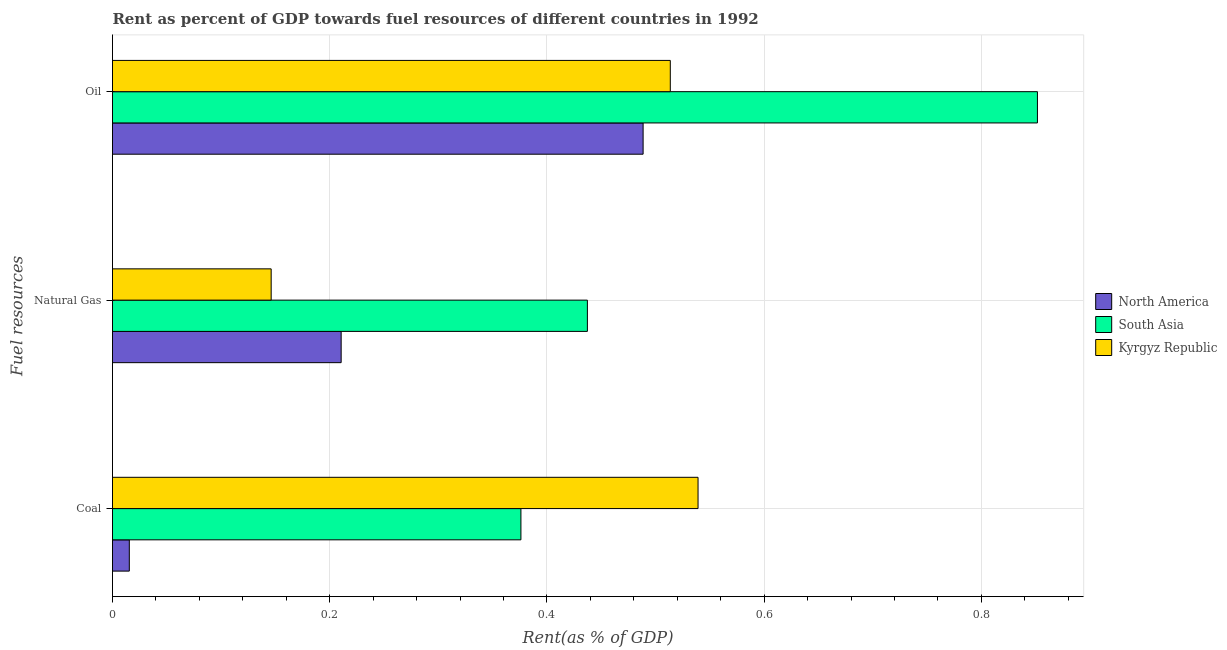How many different coloured bars are there?
Provide a succinct answer. 3. How many groups of bars are there?
Your response must be concise. 3. Are the number of bars on each tick of the Y-axis equal?
Keep it short and to the point. Yes. How many bars are there on the 2nd tick from the bottom?
Give a very brief answer. 3. What is the label of the 2nd group of bars from the top?
Your answer should be very brief. Natural Gas. What is the rent towards coal in Kyrgyz Republic?
Keep it short and to the point. 0.54. Across all countries, what is the maximum rent towards natural gas?
Keep it short and to the point. 0.44. Across all countries, what is the minimum rent towards natural gas?
Provide a succinct answer. 0.15. In which country was the rent towards coal maximum?
Give a very brief answer. Kyrgyz Republic. In which country was the rent towards natural gas minimum?
Your answer should be very brief. Kyrgyz Republic. What is the total rent towards oil in the graph?
Ensure brevity in your answer.  1.85. What is the difference between the rent towards coal in South Asia and that in North America?
Your response must be concise. 0.36. What is the difference between the rent towards natural gas in North America and the rent towards coal in South Asia?
Keep it short and to the point. -0.17. What is the average rent towards coal per country?
Offer a very short reply. 0.31. What is the difference between the rent towards natural gas and rent towards coal in Kyrgyz Republic?
Offer a very short reply. -0.39. What is the ratio of the rent towards coal in Kyrgyz Republic to that in South Asia?
Provide a short and direct response. 1.43. What is the difference between the highest and the second highest rent towards natural gas?
Offer a very short reply. 0.23. What is the difference between the highest and the lowest rent towards natural gas?
Keep it short and to the point. 0.29. Is the sum of the rent towards coal in South Asia and North America greater than the maximum rent towards natural gas across all countries?
Your answer should be very brief. No. What does the 3rd bar from the top in Coal represents?
Give a very brief answer. North America. What does the 3rd bar from the bottom in Natural Gas represents?
Provide a succinct answer. Kyrgyz Republic. How many bars are there?
Provide a short and direct response. 9. Are the values on the major ticks of X-axis written in scientific E-notation?
Keep it short and to the point. No. Does the graph contain any zero values?
Your answer should be very brief. No. Does the graph contain grids?
Give a very brief answer. Yes. What is the title of the graph?
Offer a very short reply. Rent as percent of GDP towards fuel resources of different countries in 1992. Does "Arab World" appear as one of the legend labels in the graph?
Ensure brevity in your answer.  No. What is the label or title of the X-axis?
Offer a terse response. Rent(as % of GDP). What is the label or title of the Y-axis?
Provide a succinct answer. Fuel resources. What is the Rent(as % of GDP) of North America in Coal?
Provide a short and direct response. 0.02. What is the Rent(as % of GDP) in South Asia in Coal?
Make the answer very short. 0.38. What is the Rent(as % of GDP) of Kyrgyz Republic in Coal?
Give a very brief answer. 0.54. What is the Rent(as % of GDP) in North America in Natural Gas?
Your response must be concise. 0.21. What is the Rent(as % of GDP) in South Asia in Natural Gas?
Your response must be concise. 0.44. What is the Rent(as % of GDP) of Kyrgyz Republic in Natural Gas?
Make the answer very short. 0.15. What is the Rent(as % of GDP) of North America in Oil?
Provide a short and direct response. 0.49. What is the Rent(as % of GDP) of South Asia in Oil?
Your answer should be very brief. 0.85. What is the Rent(as % of GDP) in Kyrgyz Republic in Oil?
Offer a terse response. 0.51. Across all Fuel resources, what is the maximum Rent(as % of GDP) in North America?
Your answer should be very brief. 0.49. Across all Fuel resources, what is the maximum Rent(as % of GDP) of South Asia?
Your answer should be compact. 0.85. Across all Fuel resources, what is the maximum Rent(as % of GDP) in Kyrgyz Republic?
Your answer should be very brief. 0.54. Across all Fuel resources, what is the minimum Rent(as % of GDP) of North America?
Provide a succinct answer. 0.02. Across all Fuel resources, what is the minimum Rent(as % of GDP) in South Asia?
Offer a very short reply. 0.38. Across all Fuel resources, what is the minimum Rent(as % of GDP) of Kyrgyz Republic?
Offer a terse response. 0.15. What is the total Rent(as % of GDP) of North America in the graph?
Provide a short and direct response. 0.71. What is the total Rent(as % of GDP) of South Asia in the graph?
Give a very brief answer. 1.66. What is the total Rent(as % of GDP) of Kyrgyz Republic in the graph?
Ensure brevity in your answer.  1.2. What is the difference between the Rent(as % of GDP) of North America in Coal and that in Natural Gas?
Keep it short and to the point. -0.2. What is the difference between the Rent(as % of GDP) of South Asia in Coal and that in Natural Gas?
Ensure brevity in your answer.  -0.06. What is the difference between the Rent(as % of GDP) in Kyrgyz Republic in Coal and that in Natural Gas?
Make the answer very short. 0.39. What is the difference between the Rent(as % of GDP) of North America in Coal and that in Oil?
Provide a short and direct response. -0.47. What is the difference between the Rent(as % of GDP) in South Asia in Coal and that in Oil?
Provide a succinct answer. -0.48. What is the difference between the Rent(as % of GDP) of Kyrgyz Republic in Coal and that in Oil?
Give a very brief answer. 0.03. What is the difference between the Rent(as % of GDP) of North America in Natural Gas and that in Oil?
Provide a short and direct response. -0.28. What is the difference between the Rent(as % of GDP) of South Asia in Natural Gas and that in Oil?
Keep it short and to the point. -0.41. What is the difference between the Rent(as % of GDP) in Kyrgyz Republic in Natural Gas and that in Oil?
Give a very brief answer. -0.37. What is the difference between the Rent(as % of GDP) of North America in Coal and the Rent(as % of GDP) of South Asia in Natural Gas?
Provide a succinct answer. -0.42. What is the difference between the Rent(as % of GDP) of North America in Coal and the Rent(as % of GDP) of Kyrgyz Republic in Natural Gas?
Your answer should be compact. -0.13. What is the difference between the Rent(as % of GDP) of South Asia in Coal and the Rent(as % of GDP) of Kyrgyz Republic in Natural Gas?
Provide a succinct answer. 0.23. What is the difference between the Rent(as % of GDP) of North America in Coal and the Rent(as % of GDP) of South Asia in Oil?
Your answer should be compact. -0.84. What is the difference between the Rent(as % of GDP) of North America in Coal and the Rent(as % of GDP) of Kyrgyz Republic in Oil?
Ensure brevity in your answer.  -0.5. What is the difference between the Rent(as % of GDP) of South Asia in Coal and the Rent(as % of GDP) of Kyrgyz Republic in Oil?
Provide a short and direct response. -0.14. What is the difference between the Rent(as % of GDP) of North America in Natural Gas and the Rent(as % of GDP) of South Asia in Oil?
Keep it short and to the point. -0.64. What is the difference between the Rent(as % of GDP) of North America in Natural Gas and the Rent(as % of GDP) of Kyrgyz Republic in Oil?
Provide a short and direct response. -0.3. What is the difference between the Rent(as % of GDP) in South Asia in Natural Gas and the Rent(as % of GDP) in Kyrgyz Republic in Oil?
Offer a terse response. -0.08. What is the average Rent(as % of GDP) of North America per Fuel resources?
Offer a terse response. 0.24. What is the average Rent(as % of GDP) of South Asia per Fuel resources?
Give a very brief answer. 0.56. What is the average Rent(as % of GDP) in Kyrgyz Republic per Fuel resources?
Your answer should be very brief. 0.4. What is the difference between the Rent(as % of GDP) in North America and Rent(as % of GDP) in South Asia in Coal?
Your answer should be very brief. -0.36. What is the difference between the Rent(as % of GDP) in North America and Rent(as % of GDP) in Kyrgyz Republic in Coal?
Your answer should be very brief. -0.52. What is the difference between the Rent(as % of GDP) in South Asia and Rent(as % of GDP) in Kyrgyz Republic in Coal?
Provide a succinct answer. -0.16. What is the difference between the Rent(as % of GDP) of North America and Rent(as % of GDP) of South Asia in Natural Gas?
Offer a very short reply. -0.23. What is the difference between the Rent(as % of GDP) in North America and Rent(as % of GDP) in Kyrgyz Republic in Natural Gas?
Keep it short and to the point. 0.06. What is the difference between the Rent(as % of GDP) in South Asia and Rent(as % of GDP) in Kyrgyz Republic in Natural Gas?
Your answer should be compact. 0.29. What is the difference between the Rent(as % of GDP) of North America and Rent(as % of GDP) of South Asia in Oil?
Offer a terse response. -0.36. What is the difference between the Rent(as % of GDP) of North America and Rent(as % of GDP) of Kyrgyz Republic in Oil?
Offer a terse response. -0.03. What is the difference between the Rent(as % of GDP) of South Asia and Rent(as % of GDP) of Kyrgyz Republic in Oil?
Offer a very short reply. 0.34. What is the ratio of the Rent(as % of GDP) in North America in Coal to that in Natural Gas?
Give a very brief answer. 0.07. What is the ratio of the Rent(as % of GDP) in South Asia in Coal to that in Natural Gas?
Offer a terse response. 0.86. What is the ratio of the Rent(as % of GDP) of Kyrgyz Republic in Coal to that in Natural Gas?
Ensure brevity in your answer.  3.69. What is the ratio of the Rent(as % of GDP) in North America in Coal to that in Oil?
Your response must be concise. 0.03. What is the ratio of the Rent(as % of GDP) in South Asia in Coal to that in Oil?
Offer a terse response. 0.44. What is the ratio of the Rent(as % of GDP) in Kyrgyz Republic in Coal to that in Oil?
Keep it short and to the point. 1.05. What is the ratio of the Rent(as % of GDP) in North America in Natural Gas to that in Oil?
Your answer should be compact. 0.43. What is the ratio of the Rent(as % of GDP) in South Asia in Natural Gas to that in Oil?
Ensure brevity in your answer.  0.51. What is the ratio of the Rent(as % of GDP) of Kyrgyz Republic in Natural Gas to that in Oil?
Your answer should be compact. 0.28. What is the difference between the highest and the second highest Rent(as % of GDP) in North America?
Give a very brief answer. 0.28. What is the difference between the highest and the second highest Rent(as % of GDP) of South Asia?
Make the answer very short. 0.41. What is the difference between the highest and the second highest Rent(as % of GDP) of Kyrgyz Republic?
Provide a succinct answer. 0.03. What is the difference between the highest and the lowest Rent(as % of GDP) in North America?
Provide a short and direct response. 0.47. What is the difference between the highest and the lowest Rent(as % of GDP) in South Asia?
Your response must be concise. 0.48. What is the difference between the highest and the lowest Rent(as % of GDP) in Kyrgyz Republic?
Give a very brief answer. 0.39. 